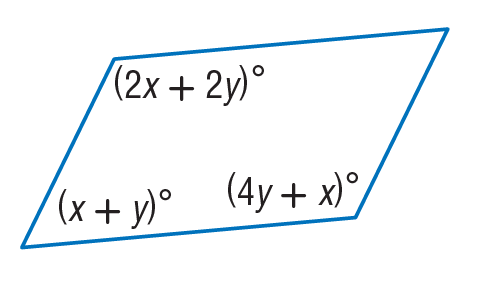Question: Find x so that the quadrilateral is a parallelogram.
Choices:
A. 30
B. 40
C. 70
D. 85
Answer with the letter. Answer: B Question: Find y so that the quadrilateral is a parallelogram.
Choices:
A. 11
B. 15
C. 20
D. 30
Answer with the letter. Answer: C 